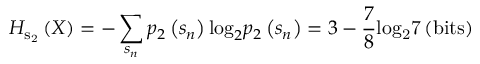<formula> <loc_0><loc_0><loc_500><loc_500>{ H _ { { { s } _ { 2 } } } } \left ( X \right ) = - \sum _ { { s _ { n } } } { { p _ { 2 } } \left ( { { s _ { n } } } \right ) { { \log } _ { 2 } } { p _ { 2 } } \left ( { { s _ { n } } } \right ) } = 3 - \frac { 7 } { 8 } { l o } { { g } _ { 2 } } { 7 } \left ( { b i t s } \right )</formula> 